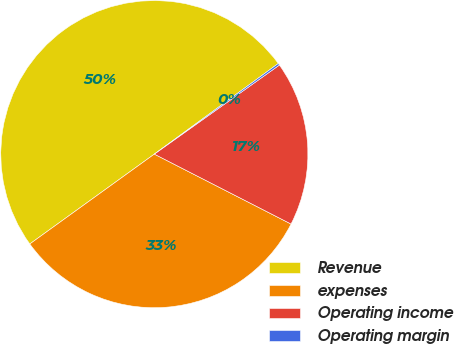<chart> <loc_0><loc_0><loc_500><loc_500><pie_chart><fcel>Revenue<fcel>expenses<fcel>Operating income<fcel>Operating margin<nl><fcel>49.9%<fcel>32.53%<fcel>17.37%<fcel>0.2%<nl></chart> 